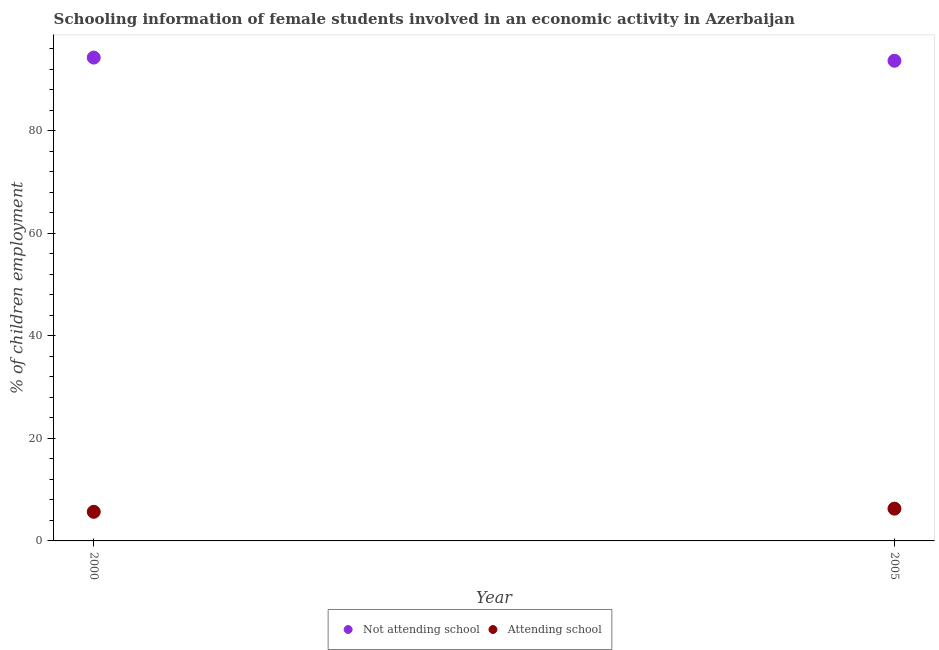Is the number of dotlines equal to the number of legend labels?
Make the answer very short. Yes. What is the percentage of employed females who are not attending school in 2005?
Provide a succinct answer. 93.7. Across all years, what is the maximum percentage of employed females who are attending school?
Give a very brief answer. 6.3. Across all years, what is the minimum percentage of employed females who are not attending school?
Provide a short and direct response. 93.7. In which year was the percentage of employed females who are attending school minimum?
Your response must be concise. 2000. What is the total percentage of employed females who are attending school in the graph?
Offer a very short reply. 11.98. What is the difference between the percentage of employed females who are attending school in 2000 and that in 2005?
Offer a very short reply. -0.62. What is the difference between the percentage of employed females who are not attending school in 2000 and the percentage of employed females who are attending school in 2005?
Ensure brevity in your answer.  88.02. What is the average percentage of employed females who are not attending school per year?
Keep it short and to the point. 94.01. In the year 2005, what is the difference between the percentage of employed females who are attending school and percentage of employed females who are not attending school?
Keep it short and to the point. -87.4. What is the ratio of the percentage of employed females who are not attending school in 2000 to that in 2005?
Ensure brevity in your answer.  1.01. Is the percentage of employed females who are not attending school in 2000 less than that in 2005?
Your answer should be very brief. No. Does the percentage of employed females who are not attending school monotonically increase over the years?
Your answer should be very brief. No. How many dotlines are there?
Your answer should be compact. 2. Does the graph contain any zero values?
Offer a very short reply. No. What is the title of the graph?
Your response must be concise. Schooling information of female students involved in an economic activity in Azerbaijan. Does "Transport services" appear as one of the legend labels in the graph?
Give a very brief answer. No. What is the label or title of the X-axis?
Offer a terse response. Year. What is the label or title of the Y-axis?
Keep it short and to the point. % of children employment. What is the % of children employment in Not attending school in 2000?
Provide a succinct answer. 94.32. What is the % of children employment of Attending school in 2000?
Offer a very short reply. 5.68. What is the % of children employment in Not attending school in 2005?
Your answer should be compact. 93.7. What is the % of children employment in Attending school in 2005?
Offer a very short reply. 6.3. Across all years, what is the maximum % of children employment of Not attending school?
Give a very brief answer. 94.32. Across all years, what is the maximum % of children employment in Attending school?
Keep it short and to the point. 6.3. Across all years, what is the minimum % of children employment of Not attending school?
Make the answer very short. 93.7. Across all years, what is the minimum % of children employment of Attending school?
Keep it short and to the point. 5.68. What is the total % of children employment in Not attending school in the graph?
Provide a succinct answer. 188.02. What is the total % of children employment in Attending school in the graph?
Offer a terse response. 11.98. What is the difference between the % of children employment of Not attending school in 2000 and that in 2005?
Provide a short and direct response. 0.62. What is the difference between the % of children employment in Attending school in 2000 and that in 2005?
Provide a short and direct response. -0.62. What is the difference between the % of children employment of Not attending school in 2000 and the % of children employment of Attending school in 2005?
Give a very brief answer. 88.02. What is the average % of children employment of Not attending school per year?
Give a very brief answer. 94.01. What is the average % of children employment in Attending school per year?
Provide a succinct answer. 5.99. In the year 2000, what is the difference between the % of children employment in Not attending school and % of children employment in Attending school?
Give a very brief answer. 88.64. In the year 2005, what is the difference between the % of children employment in Not attending school and % of children employment in Attending school?
Offer a very short reply. 87.4. What is the ratio of the % of children employment in Not attending school in 2000 to that in 2005?
Your response must be concise. 1.01. What is the ratio of the % of children employment in Attending school in 2000 to that in 2005?
Your response must be concise. 0.9. What is the difference between the highest and the second highest % of children employment in Not attending school?
Provide a succinct answer. 0.62. What is the difference between the highest and the second highest % of children employment in Attending school?
Give a very brief answer. 0.62. What is the difference between the highest and the lowest % of children employment in Not attending school?
Keep it short and to the point. 0.62. What is the difference between the highest and the lowest % of children employment in Attending school?
Your response must be concise. 0.62. 